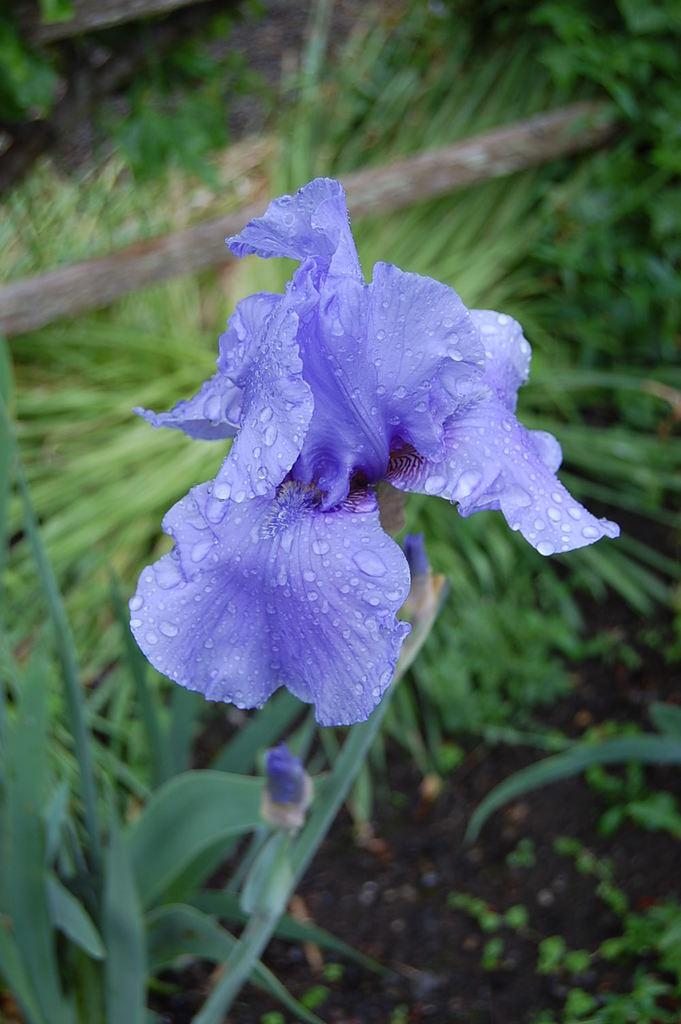What type of flowers can be seen on the plant in the image? There are purple color flowers on a plant in the image. What can be seen in the background of the image? There is a wooden log and grass in the background of the image. Are there any other plants visible in the image? Yes, there are additional plants in the background of the image. What is the manager doing in the image? There is no manager present in the image. Is the vase holding the flowers in the image? There is no vase mentioned in the image; the flowers are on a plant. 